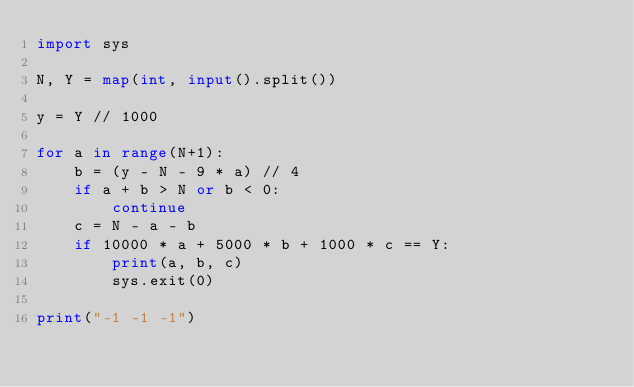Convert code to text. <code><loc_0><loc_0><loc_500><loc_500><_Python_>import sys

N, Y = map(int, input().split())

y = Y // 1000

for a in range(N+1):
    b = (y - N - 9 * a) // 4
    if a + b > N or b < 0:
        continue
    c = N - a - b
    if 10000 * a + 5000 * b + 1000 * c == Y:
        print(a, b, c)
        sys.exit(0)

print("-1 -1 -1")
</code> 